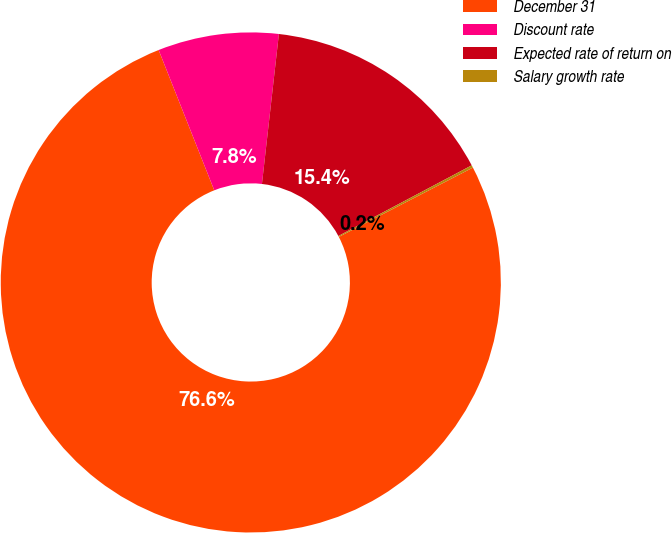Convert chart. <chart><loc_0><loc_0><loc_500><loc_500><pie_chart><fcel>December 31<fcel>Discount rate<fcel>Expected rate of return on<fcel>Salary growth rate<nl><fcel>76.59%<fcel>7.8%<fcel>15.45%<fcel>0.16%<nl></chart> 